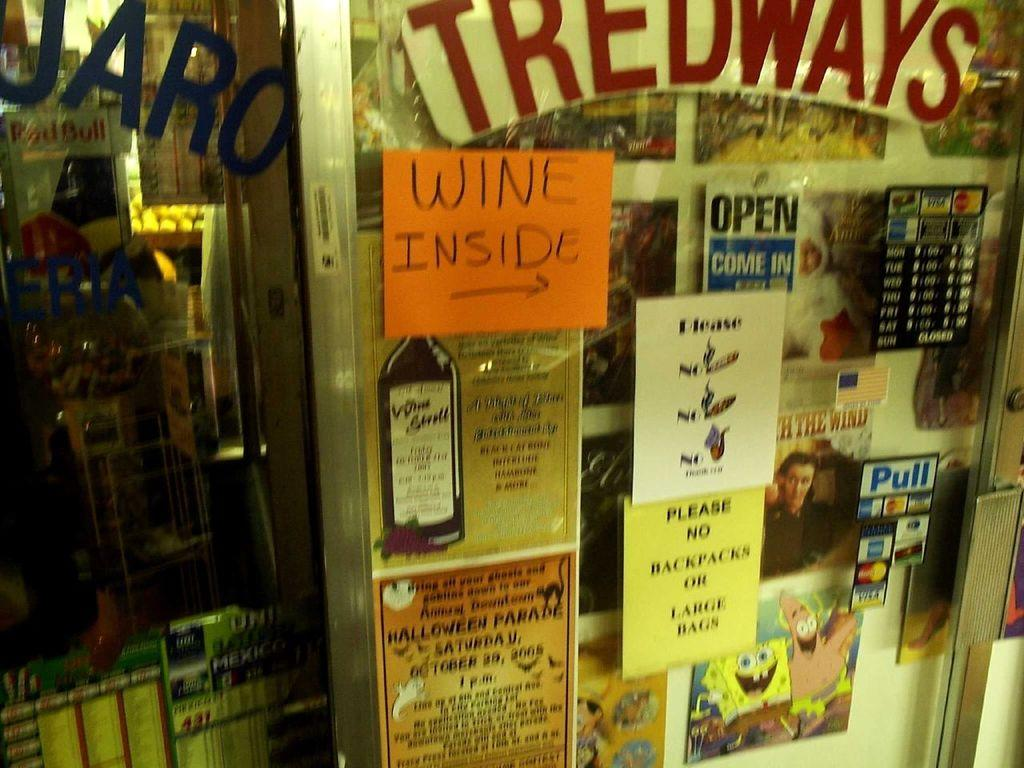Provide a one-sentence caption for the provided image. Tredways sells wine but does not allow backpacks or large bags. 